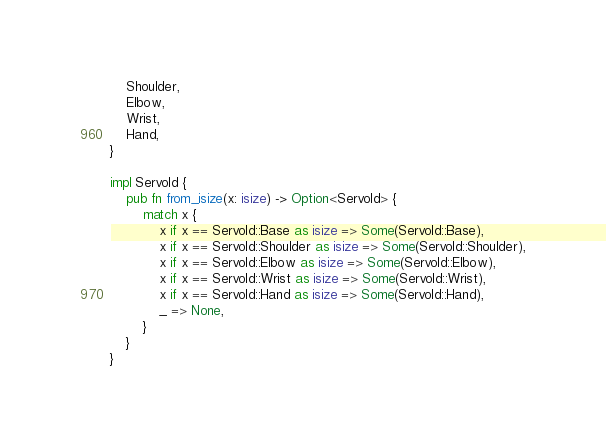<code> <loc_0><loc_0><loc_500><loc_500><_Rust_>    Shoulder,
    Elbow,
    Wrist,
    Hand,
}

impl ServoId {
    pub fn from_isize(x: isize) -> Option<ServoId> {
        match x {
            x if x == ServoId::Base as isize => Some(ServoId::Base),
            x if x == ServoId::Shoulder as isize => Some(ServoId::Shoulder),
            x if x == ServoId::Elbow as isize => Some(ServoId::Elbow),
            x if x == ServoId::Wrist as isize => Some(ServoId::Wrist),
            x if x == ServoId::Hand as isize => Some(ServoId::Hand),
            _ => None,
        }
    }
}
</code> 